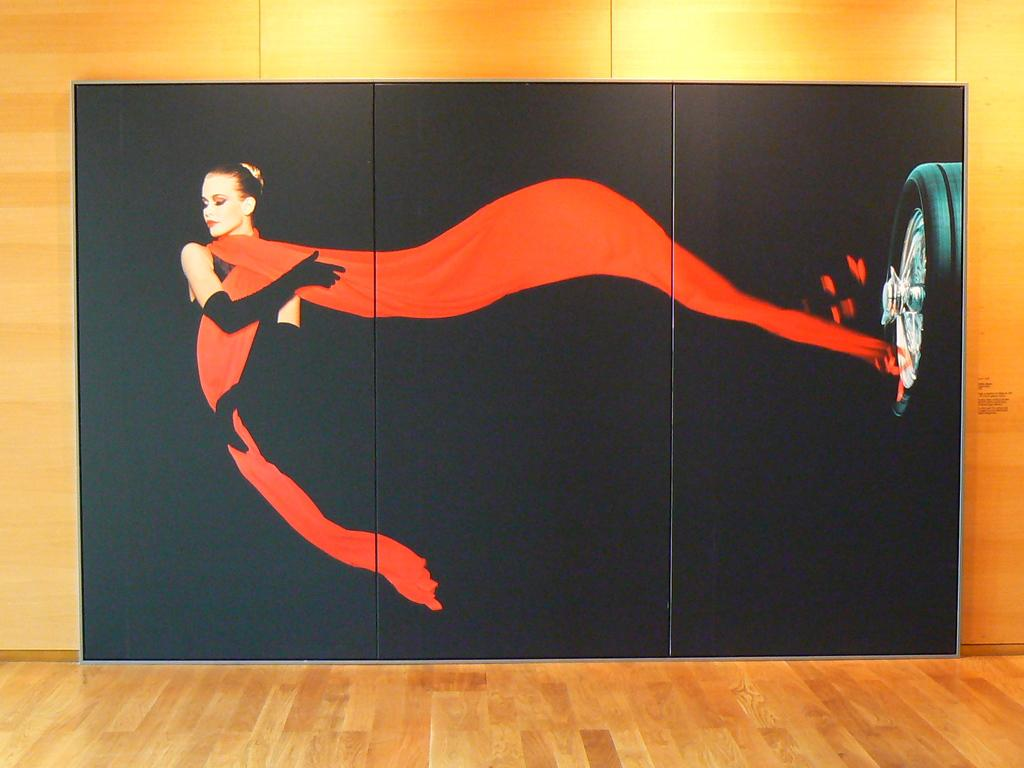What is depicted in the painting that is visible in the image? There is a painting of a woman in the image. What other object can be seen in the image besides the painting? There is a wheel of a vehicle in the image. Where are the painting and wheel located in the image? The painting and wheel are on a wall in the image. What is visible at the bottom of the image? There is a floor visible at the bottom of the image. What type of cloud is depicted in the painting? There is no cloud depicted in the painting; it features a woman. 